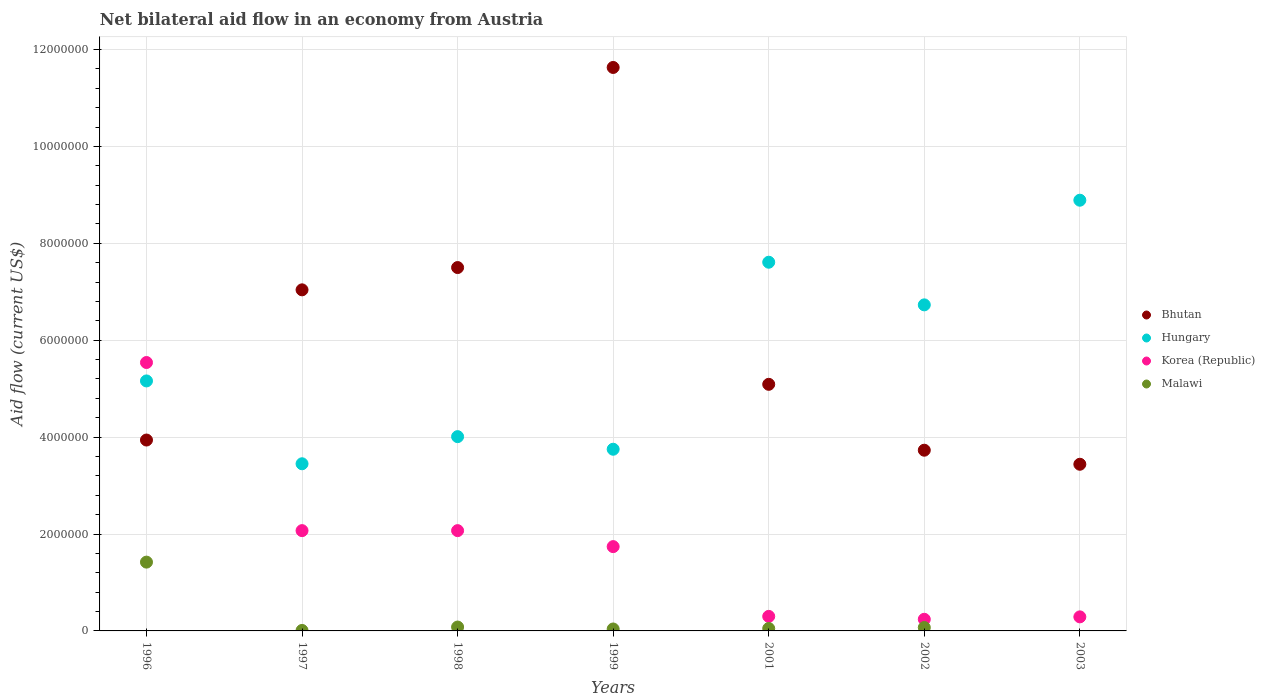How many different coloured dotlines are there?
Your answer should be very brief. 4. What is the net bilateral aid flow in Korea (Republic) in 1997?
Make the answer very short. 2.07e+06. Across all years, what is the maximum net bilateral aid flow in Malawi?
Keep it short and to the point. 1.42e+06. Across all years, what is the minimum net bilateral aid flow in Hungary?
Provide a short and direct response. 3.45e+06. What is the total net bilateral aid flow in Korea (Republic) in the graph?
Offer a terse response. 1.22e+07. What is the difference between the net bilateral aid flow in Hungary in 1998 and the net bilateral aid flow in Malawi in 2003?
Make the answer very short. 4.01e+06. What is the average net bilateral aid flow in Korea (Republic) per year?
Keep it short and to the point. 1.75e+06. In the year 1999, what is the difference between the net bilateral aid flow in Bhutan and net bilateral aid flow in Hungary?
Ensure brevity in your answer.  7.88e+06. What is the ratio of the net bilateral aid flow in Korea (Republic) in 1996 to that in 1999?
Your answer should be very brief. 3.18. Is the net bilateral aid flow in Malawi in 1997 less than that in 1999?
Ensure brevity in your answer.  Yes. Is the difference between the net bilateral aid flow in Bhutan in 1999 and 2003 greater than the difference between the net bilateral aid flow in Hungary in 1999 and 2003?
Provide a succinct answer. Yes. What is the difference between the highest and the second highest net bilateral aid flow in Korea (Republic)?
Your response must be concise. 3.47e+06. What is the difference between the highest and the lowest net bilateral aid flow in Malawi?
Your answer should be compact. 1.42e+06. Is the sum of the net bilateral aid flow in Korea (Republic) in 1999 and 2003 greater than the maximum net bilateral aid flow in Bhutan across all years?
Offer a terse response. No. Is the net bilateral aid flow in Bhutan strictly greater than the net bilateral aid flow in Hungary over the years?
Your answer should be compact. No. Is the net bilateral aid flow in Korea (Republic) strictly less than the net bilateral aid flow in Malawi over the years?
Keep it short and to the point. No. How many dotlines are there?
Your response must be concise. 4. What is the difference between two consecutive major ticks on the Y-axis?
Offer a very short reply. 2.00e+06. Does the graph contain grids?
Make the answer very short. Yes. How many legend labels are there?
Your answer should be compact. 4. What is the title of the graph?
Offer a terse response. Net bilateral aid flow in an economy from Austria. Does "Japan" appear as one of the legend labels in the graph?
Your answer should be very brief. No. What is the label or title of the Y-axis?
Offer a terse response. Aid flow (current US$). What is the Aid flow (current US$) of Bhutan in 1996?
Offer a terse response. 3.94e+06. What is the Aid flow (current US$) of Hungary in 1996?
Give a very brief answer. 5.16e+06. What is the Aid flow (current US$) of Korea (Republic) in 1996?
Your answer should be very brief. 5.54e+06. What is the Aid flow (current US$) in Malawi in 1996?
Make the answer very short. 1.42e+06. What is the Aid flow (current US$) in Bhutan in 1997?
Make the answer very short. 7.04e+06. What is the Aid flow (current US$) in Hungary in 1997?
Offer a terse response. 3.45e+06. What is the Aid flow (current US$) in Korea (Republic) in 1997?
Offer a very short reply. 2.07e+06. What is the Aid flow (current US$) in Bhutan in 1998?
Provide a succinct answer. 7.50e+06. What is the Aid flow (current US$) of Hungary in 1998?
Your answer should be compact. 4.01e+06. What is the Aid flow (current US$) of Korea (Republic) in 1998?
Make the answer very short. 2.07e+06. What is the Aid flow (current US$) of Bhutan in 1999?
Provide a succinct answer. 1.16e+07. What is the Aid flow (current US$) of Hungary in 1999?
Ensure brevity in your answer.  3.75e+06. What is the Aid flow (current US$) in Korea (Republic) in 1999?
Offer a very short reply. 1.74e+06. What is the Aid flow (current US$) in Malawi in 1999?
Make the answer very short. 4.00e+04. What is the Aid flow (current US$) in Bhutan in 2001?
Your response must be concise. 5.09e+06. What is the Aid flow (current US$) in Hungary in 2001?
Your response must be concise. 7.61e+06. What is the Aid flow (current US$) of Bhutan in 2002?
Keep it short and to the point. 3.73e+06. What is the Aid flow (current US$) in Hungary in 2002?
Your answer should be compact. 6.73e+06. What is the Aid flow (current US$) of Korea (Republic) in 2002?
Offer a very short reply. 2.40e+05. What is the Aid flow (current US$) in Malawi in 2002?
Give a very brief answer. 7.00e+04. What is the Aid flow (current US$) in Bhutan in 2003?
Give a very brief answer. 3.44e+06. What is the Aid flow (current US$) of Hungary in 2003?
Keep it short and to the point. 8.89e+06. Across all years, what is the maximum Aid flow (current US$) in Bhutan?
Offer a terse response. 1.16e+07. Across all years, what is the maximum Aid flow (current US$) in Hungary?
Ensure brevity in your answer.  8.89e+06. Across all years, what is the maximum Aid flow (current US$) in Korea (Republic)?
Offer a terse response. 5.54e+06. Across all years, what is the maximum Aid flow (current US$) in Malawi?
Provide a short and direct response. 1.42e+06. Across all years, what is the minimum Aid flow (current US$) of Bhutan?
Give a very brief answer. 3.44e+06. Across all years, what is the minimum Aid flow (current US$) of Hungary?
Provide a short and direct response. 3.45e+06. Across all years, what is the minimum Aid flow (current US$) in Malawi?
Your answer should be compact. 0. What is the total Aid flow (current US$) of Bhutan in the graph?
Your answer should be very brief. 4.24e+07. What is the total Aid flow (current US$) in Hungary in the graph?
Ensure brevity in your answer.  3.96e+07. What is the total Aid flow (current US$) in Korea (Republic) in the graph?
Provide a succinct answer. 1.22e+07. What is the total Aid flow (current US$) in Malawi in the graph?
Offer a very short reply. 1.67e+06. What is the difference between the Aid flow (current US$) of Bhutan in 1996 and that in 1997?
Ensure brevity in your answer.  -3.10e+06. What is the difference between the Aid flow (current US$) in Hungary in 1996 and that in 1997?
Your answer should be compact. 1.71e+06. What is the difference between the Aid flow (current US$) of Korea (Republic) in 1996 and that in 1997?
Provide a succinct answer. 3.47e+06. What is the difference between the Aid flow (current US$) of Malawi in 1996 and that in 1997?
Your answer should be very brief. 1.41e+06. What is the difference between the Aid flow (current US$) in Bhutan in 1996 and that in 1998?
Keep it short and to the point. -3.56e+06. What is the difference between the Aid flow (current US$) of Hungary in 1996 and that in 1998?
Ensure brevity in your answer.  1.15e+06. What is the difference between the Aid flow (current US$) of Korea (Republic) in 1996 and that in 1998?
Provide a short and direct response. 3.47e+06. What is the difference between the Aid flow (current US$) of Malawi in 1996 and that in 1998?
Offer a very short reply. 1.34e+06. What is the difference between the Aid flow (current US$) in Bhutan in 1996 and that in 1999?
Your response must be concise. -7.69e+06. What is the difference between the Aid flow (current US$) in Hungary in 1996 and that in 1999?
Give a very brief answer. 1.41e+06. What is the difference between the Aid flow (current US$) in Korea (Republic) in 1996 and that in 1999?
Provide a short and direct response. 3.80e+06. What is the difference between the Aid flow (current US$) of Malawi in 1996 and that in 1999?
Provide a short and direct response. 1.38e+06. What is the difference between the Aid flow (current US$) in Bhutan in 1996 and that in 2001?
Ensure brevity in your answer.  -1.15e+06. What is the difference between the Aid flow (current US$) of Hungary in 1996 and that in 2001?
Offer a terse response. -2.45e+06. What is the difference between the Aid flow (current US$) in Korea (Republic) in 1996 and that in 2001?
Provide a short and direct response. 5.24e+06. What is the difference between the Aid flow (current US$) of Malawi in 1996 and that in 2001?
Provide a succinct answer. 1.37e+06. What is the difference between the Aid flow (current US$) in Hungary in 1996 and that in 2002?
Offer a very short reply. -1.57e+06. What is the difference between the Aid flow (current US$) of Korea (Republic) in 1996 and that in 2002?
Keep it short and to the point. 5.30e+06. What is the difference between the Aid flow (current US$) in Malawi in 1996 and that in 2002?
Offer a terse response. 1.35e+06. What is the difference between the Aid flow (current US$) in Bhutan in 1996 and that in 2003?
Your answer should be very brief. 5.00e+05. What is the difference between the Aid flow (current US$) in Hungary in 1996 and that in 2003?
Keep it short and to the point. -3.73e+06. What is the difference between the Aid flow (current US$) in Korea (Republic) in 1996 and that in 2003?
Offer a terse response. 5.25e+06. What is the difference between the Aid flow (current US$) in Bhutan in 1997 and that in 1998?
Provide a short and direct response. -4.60e+05. What is the difference between the Aid flow (current US$) of Hungary in 1997 and that in 1998?
Provide a short and direct response. -5.60e+05. What is the difference between the Aid flow (current US$) in Malawi in 1997 and that in 1998?
Your response must be concise. -7.00e+04. What is the difference between the Aid flow (current US$) of Bhutan in 1997 and that in 1999?
Give a very brief answer. -4.59e+06. What is the difference between the Aid flow (current US$) in Hungary in 1997 and that in 1999?
Give a very brief answer. -3.00e+05. What is the difference between the Aid flow (current US$) in Bhutan in 1997 and that in 2001?
Offer a very short reply. 1.95e+06. What is the difference between the Aid flow (current US$) in Hungary in 1997 and that in 2001?
Offer a terse response. -4.16e+06. What is the difference between the Aid flow (current US$) in Korea (Republic) in 1997 and that in 2001?
Make the answer very short. 1.77e+06. What is the difference between the Aid flow (current US$) in Malawi in 1997 and that in 2001?
Provide a short and direct response. -4.00e+04. What is the difference between the Aid flow (current US$) in Bhutan in 1997 and that in 2002?
Your answer should be compact. 3.31e+06. What is the difference between the Aid flow (current US$) of Hungary in 1997 and that in 2002?
Your response must be concise. -3.28e+06. What is the difference between the Aid flow (current US$) of Korea (Republic) in 1997 and that in 2002?
Provide a short and direct response. 1.83e+06. What is the difference between the Aid flow (current US$) in Malawi in 1997 and that in 2002?
Make the answer very short. -6.00e+04. What is the difference between the Aid flow (current US$) in Bhutan in 1997 and that in 2003?
Provide a short and direct response. 3.60e+06. What is the difference between the Aid flow (current US$) of Hungary in 1997 and that in 2003?
Ensure brevity in your answer.  -5.44e+06. What is the difference between the Aid flow (current US$) of Korea (Republic) in 1997 and that in 2003?
Offer a terse response. 1.78e+06. What is the difference between the Aid flow (current US$) in Bhutan in 1998 and that in 1999?
Provide a succinct answer. -4.13e+06. What is the difference between the Aid flow (current US$) of Hungary in 1998 and that in 1999?
Your answer should be compact. 2.60e+05. What is the difference between the Aid flow (current US$) in Bhutan in 1998 and that in 2001?
Provide a succinct answer. 2.41e+06. What is the difference between the Aid flow (current US$) of Hungary in 1998 and that in 2001?
Give a very brief answer. -3.60e+06. What is the difference between the Aid flow (current US$) in Korea (Republic) in 1998 and that in 2001?
Offer a terse response. 1.77e+06. What is the difference between the Aid flow (current US$) in Malawi in 1998 and that in 2001?
Ensure brevity in your answer.  3.00e+04. What is the difference between the Aid flow (current US$) of Bhutan in 1998 and that in 2002?
Keep it short and to the point. 3.77e+06. What is the difference between the Aid flow (current US$) of Hungary in 1998 and that in 2002?
Give a very brief answer. -2.72e+06. What is the difference between the Aid flow (current US$) of Korea (Republic) in 1998 and that in 2002?
Provide a succinct answer. 1.83e+06. What is the difference between the Aid flow (current US$) in Malawi in 1998 and that in 2002?
Make the answer very short. 10000. What is the difference between the Aid flow (current US$) of Bhutan in 1998 and that in 2003?
Keep it short and to the point. 4.06e+06. What is the difference between the Aid flow (current US$) in Hungary in 1998 and that in 2003?
Keep it short and to the point. -4.88e+06. What is the difference between the Aid flow (current US$) of Korea (Republic) in 1998 and that in 2003?
Give a very brief answer. 1.78e+06. What is the difference between the Aid flow (current US$) of Bhutan in 1999 and that in 2001?
Your answer should be compact. 6.54e+06. What is the difference between the Aid flow (current US$) of Hungary in 1999 and that in 2001?
Make the answer very short. -3.86e+06. What is the difference between the Aid flow (current US$) of Korea (Republic) in 1999 and that in 2001?
Your answer should be compact. 1.44e+06. What is the difference between the Aid flow (current US$) in Bhutan in 1999 and that in 2002?
Give a very brief answer. 7.90e+06. What is the difference between the Aid flow (current US$) in Hungary in 1999 and that in 2002?
Provide a succinct answer. -2.98e+06. What is the difference between the Aid flow (current US$) in Korea (Republic) in 1999 and that in 2002?
Provide a succinct answer. 1.50e+06. What is the difference between the Aid flow (current US$) in Bhutan in 1999 and that in 2003?
Provide a short and direct response. 8.19e+06. What is the difference between the Aid flow (current US$) in Hungary in 1999 and that in 2003?
Your answer should be very brief. -5.14e+06. What is the difference between the Aid flow (current US$) in Korea (Republic) in 1999 and that in 2003?
Provide a succinct answer. 1.45e+06. What is the difference between the Aid flow (current US$) in Bhutan in 2001 and that in 2002?
Your answer should be compact. 1.36e+06. What is the difference between the Aid flow (current US$) of Hungary in 2001 and that in 2002?
Give a very brief answer. 8.80e+05. What is the difference between the Aid flow (current US$) in Korea (Republic) in 2001 and that in 2002?
Provide a short and direct response. 6.00e+04. What is the difference between the Aid flow (current US$) in Bhutan in 2001 and that in 2003?
Keep it short and to the point. 1.65e+06. What is the difference between the Aid flow (current US$) of Hungary in 2001 and that in 2003?
Provide a short and direct response. -1.28e+06. What is the difference between the Aid flow (current US$) of Korea (Republic) in 2001 and that in 2003?
Your response must be concise. 10000. What is the difference between the Aid flow (current US$) in Hungary in 2002 and that in 2003?
Keep it short and to the point. -2.16e+06. What is the difference between the Aid flow (current US$) in Bhutan in 1996 and the Aid flow (current US$) in Hungary in 1997?
Offer a very short reply. 4.90e+05. What is the difference between the Aid flow (current US$) of Bhutan in 1996 and the Aid flow (current US$) of Korea (Republic) in 1997?
Your answer should be very brief. 1.87e+06. What is the difference between the Aid flow (current US$) of Bhutan in 1996 and the Aid flow (current US$) of Malawi in 1997?
Offer a terse response. 3.93e+06. What is the difference between the Aid flow (current US$) in Hungary in 1996 and the Aid flow (current US$) in Korea (Republic) in 1997?
Provide a succinct answer. 3.09e+06. What is the difference between the Aid flow (current US$) of Hungary in 1996 and the Aid flow (current US$) of Malawi in 1997?
Provide a short and direct response. 5.15e+06. What is the difference between the Aid flow (current US$) of Korea (Republic) in 1996 and the Aid flow (current US$) of Malawi in 1997?
Your answer should be compact. 5.53e+06. What is the difference between the Aid flow (current US$) in Bhutan in 1996 and the Aid flow (current US$) in Hungary in 1998?
Your answer should be very brief. -7.00e+04. What is the difference between the Aid flow (current US$) in Bhutan in 1996 and the Aid flow (current US$) in Korea (Republic) in 1998?
Provide a succinct answer. 1.87e+06. What is the difference between the Aid flow (current US$) of Bhutan in 1996 and the Aid flow (current US$) of Malawi in 1998?
Your response must be concise. 3.86e+06. What is the difference between the Aid flow (current US$) of Hungary in 1996 and the Aid flow (current US$) of Korea (Republic) in 1998?
Make the answer very short. 3.09e+06. What is the difference between the Aid flow (current US$) in Hungary in 1996 and the Aid flow (current US$) in Malawi in 1998?
Make the answer very short. 5.08e+06. What is the difference between the Aid flow (current US$) of Korea (Republic) in 1996 and the Aid flow (current US$) of Malawi in 1998?
Offer a very short reply. 5.46e+06. What is the difference between the Aid flow (current US$) in Bhutan in 1996 and the Aid flow (current US$) in Korea (Republic) in 1999?
Offer a very short reply. 2.20e+06. What is the difference between the Aid flow (current US$) of Bhutan in 1996 and the Aid flow (current US$) of Malawi in 1999?
Provide a short and direct response. 3.90e+06. What is the difference between the Aid flow (current US$) of Hungary in 1996 and the Aid flow (current US$) of Korea (Republic) in 1999?
Make the answer very short. 3.42e+06. What is the difference between the Aid flow (current US$) of Hungary in 1996 and the Aid flow (current US$) of Malawi in 1999?
Make the answer very short. 5.12e+06. What is the difference between the Aid flow (current US$) of Korea (Republic) in 1996 and the Aid flow (current US$) of Malawi in 1999?
Ensure brevity in your answer.  5.50e+06. What is the difference between the Aid flow (current US$) in Bhutan in 1996 and the Aid flow (current US$) in Hungary in 2001?
Make the answer very short. -3.67e+06. What is the difference between the Aid flow (current US$) of Bhutan in 1996 and the Aid flow (current US$) of Korea (Republic) in 2001?
Your response must be concise. 3.64e+06. What is the difference between the Aid flow (current US$) of Bhutan in 1996 and the Aid flow (current US$) of Malawi in 2001?
Offer a very short reply. 3.89e+06. What is the difference between the Aid flow (current US$) of Hungary in 1996 and the Aid flow (current US$) of Korea (Republic) in 2001?
Your answer should be very brief. 4.86e+06. What is the difference between the Aid flow (current US$) of Hungary in 1996 and the Aid flow (current US$) of Malawi in 2001?
Make the answer very short. 5.11e+06. What is the difference between the Aid flow (current US$) in Korea (Republic) in 1996 and the Aid flow (current US$) in Malawi in 2001?
Provide a succinct answer. 5.49e+06. What is the difference between the Aid flow (current US$) of Bhutan in 1996 and the Aid flow (current US$) of Hungary in 2002?
Give a very brief answer. -2.79e+06. What is the difference between the Aid flow (current US$) of Bhutan in 1996 and the Aid flow (current US$) of Korea (Republic) in 2002?
Make the answer very short. 3.70e+06. What is the difference between the Aid flow (current US$) of Bhutan in 1996 and the Aid flow (current US$) of Malawi in 2002?
Ensure brevity in your answer.  3.87e+06. What is the difference between the Aid flow (current US$) in Hungary in 1996 and the Aid flow (current US$) in Korea (Republic) in 2002?
Your answer should be compact. 4.92e+06. What is the difference between the Aid flow (current US$) of Hungary in 1996 and the Aid flow (current US$) of Malawi in 2002?
Make the answer very short. 5.09e+06. What is the difference between the Aid flow (current US$) of Korea (Republic) in 1996 and the Aid flow (current US$) of Malawi in 2002?
Provide a short and direct response. 5.47e+06. What is the difference between the Aid flow (current US$) of Bhutan in 1996 and the Aid flow (current US$) of Hungary in 2003?
Offer a terse response. -4.95e+06. What is the difference between the Aid flow (current US$) of Bhutan in 1996 and the Aid flow (current US$) of Korea (Republic) in 2003?
Offer a terse response. 3.65e+06. What is the difference between the Aid flow (current US$) in Hungary in 1996 and the Aid flow (current US$) in Korea (Republic) in 2003?
Provide a short and direct response. 4.87e+06. What is the difference between the Aid flow (current US$) of Bhutan in 1997 and the Aid flow (current US$) of Hungary in 1998?
Give a very brief answer. 3.03e+06. What is the difference between the Aid flow (current US$) of Bhutan in 1997 and the Aid flow (current US$) of Korea (Republic) in 1998?
Keep it short and to the point. 4.97e+06. What is the difference between the Aid flow (current US$) in Bhutan in 1997 and the Aid flow (current US$) in Malawi in 1998?
Provide a short and direct response. 6.96e+06. What is the difference between the Aid flow (current US$) of Hungary in 1997 and the Aid flow (current US$) of Korea (Republic) in 1998?
Your answer should be compact. 1.38e+06. What is the difference between the Aid flow (current US$) of Hungary in 1997 and the Aid flow (current US$) of Malawi in 1998?
Provide a succinct answer. 3.37e+06. What is the difference between the Aid flow (current US$) in Korea (Republic) in 1997 and the Aid flow (current US$) in Malawi in 1998?
Offer a very short reply. 1.99e+06. What is the difference between the Aid flow (current US$) of Bhutan in 1997 and the Aid flow (current US$) of Hungary in 1999?
Keep it short and to the point. 3.29e+06. What is the difference between the Aid flow (current US$) of Bhutan in 1997 and the Aid flow (current US$) of Korea (Republic) in 1999?
Ensure brevity in your answer.  5.30e+06. What is the difference between the Aid flow (current US$) in Hungary in 1997 and the Aid flow (current US$) in Korea (Republic) in 1999?
Provide a short and direct response. 1.71e+06. What is the difference between the Aid flow (current US$) in Hungary in 1997 and the Aid flow (current US$) in Malawi in 1999?
Provide a short and direct response. 3.41e+06. What is the difference between the Aid flow (current US$) in Korea (Republic) in 1997 and the Aid flow (current US$) in Malawi in 1999?
Make the answer very short. 2.03e+06. What is the difference between the Aid flow (current US$) of Bhutan in 1997 and the Aid flow (current US$) of Hungary in 2001?
Ensure brevity in your answer.  -5.70e+05. What is the difference between the Aid flow (current US$) in Bhutan in 1997 and the Aid flow (current US$) in Korea (Republic) in 2001?
Provide a short and direct response. 6.74e+06. What is the difference between the Aid flow (current US$) of Bhutan in 1997 and the Aid flow (current US$) of Malawi in 2001?
Your response must be concise. 6.99e+06. What is the difference between the Aid flow (current US$) in Hungary in 1997 and the Aid flow (current US$) in Korea (Republic) in 2001?
Your response must be concise. 3.15e+06. What is the difference between the Aid flow (current US$) of Hungary in 1997 and the Aid flow (current US$) of Malawi in 2001?
Your response must be concise. 3.40e+06. What is the difference between the Aid flow (current US$) in Korea (Republic) in 1997 and the Aid flow (current US$) in Malawi in 2001?
Offer a very short reply. 2.02e+06. What is the difference between the Aid flow (current US$) of Bhutan in 1997 and the Aid flow (current US$) of Hungary in 2002?
Give a very brief answer. 3.10e+05. What is the difference between the Aid flow (current US$) in Bhutan in 1997 and the Aid flow (current US$) in Korea (Republic) in 2002?
Offer a very short reply. 6.80e+06. What is the difference between the Aid flow (current US$) of Bhutan in 1997 and the Aid flow (current US$) of Malawi in 2002?
Your answer should be very brief. 6.97e+06. What is the difference between the Aid flow (current US$) of Hungary in 1997 and the Aid flow (current US$) of Korea (Republic) in 2002?
Your answer should be very brief. 3.21e+06. What is the difference between the Aid flow (current US$) in Hungary in 1997 and the Aid flow (current US$) in Malawi in 2002?
Keep it short and to the point. 3.38e+06. What is the difference between the Aid flow (current US$) in Korea (Republic) in 1997 and the Aid flow (current US$) in Malawi in 2002?
Offer a very short reply. 2.00e+06. What is the difference between the Aid flow (current US$) of Bhutan in 1997 and the Aid flow (current US$) of Hungary in 2003?
Offer a very short reply. -1.85e+06. What is the difference between the Aid flow (current US$) of Bhutan in 1997 and the Aid flow (current US$) of Korea (Republic) in 2003?
Your answer should be compact. 6.75e+06. What is the difference between the Aid flow (current US$) of Hungary in 1997 and the Aid flow (current US$) of Korea (Republic) in 2003?
Make the answer very short. 3.16e+06. What is the difference between the Aid flow (current US$) in Bhutan in 1998 and the Aid flow (current US$) in Hungary in 1999?
Your answer should be compact. 3.75e+06. What is the difference between the Aid flow (current US$) in Bhutan in 1998 and the Aid flow (current US$) in Korea (Republic) in 1999?
Your answer should be very brief. 5.76e+06. What is the difference between the Aid flow (current US$) in Bhutan in 1998 and the Aid flow (current US$) in Malawi in 1999?
Make the answer very short. 7.46e+06. What is the difference between the Aid flow (current US$) in Hungary in 1998 and the Aid flow (current US$) in Korea (Republic) in 1999?
Make the answer very short. 2.27e+06. What is the difference between the Aid flow (current US$) in Hungary in 1998 and the Aid flow (current US$) in Malawi in 1999?
Ensure brevity in your answer.  3.97e+06. What is the difference between the Aid flow (current US$) of Korea (Republic) in 1998 and the Aid flow (current US$) of Malawi in 1999?
Offer a terse response. 2.03e+06. What is the difference between the Aid flow (current US$) of Bhutan in 1998 and the Aid flow (current US$) of Hungary in 2001?
Provide a succinct answer. -1.10e+05. What is the difference between the Aid flow (current US$) of Bhutan in 1998 and the Aid flow (current US$) of Korea (Republic) in 2001?
Your answer should be very brief. 7.20e+06. What is the difference between the Aid flow (current US$) of Bhutan in 1998 and the Aid flow (current US$) of Malawi in 2001?
Give a very brief answer. 7.45e+06. What is the difference between the Aid flow (current US$) in Hungary in 1998 and the Aid flow (current US$) in Korea (Republic) in 2001?
Your answer should be very brief. 3.71e+06. What is the difference between the Aid flow (current US$) in Hungary in 1998 and the Aid flow (current US$) in Malawi in 2001?
Make the answer very short. 3.96e+06. What is the difference between the Aid flow (current US$) of Korea (Republic) in 1998 and the Aid flow (current US$) of Malawi in 2001?
Offer a terse response. 2.02e+06. What is the difference between the Aid flow (current US$) of Bhutan in 1998 and the Aid flow (current US$) of Hungary in 2002?
Keep it short and to the point. 7.70e+05. What is the difference between the Aid flow (current US$) in Bhutan in 1998 and the Aid flow (current US$) in Korea (Republic) in 2002?
Offer a terse response. 7.26e+06. What is the difference between the Aid flow (current US$) of Bhutan in 1998 and the Aid flow (current US$) of Malawi in 2002?
Your response must be concise. 7.43e+06. What is the difference between the Aid flow (current US$) in Hungary in 1998 and the Aid flow (current US$) in Korea (Republic) in 2002?
Offer a very short reply. 3.77e+06. What is the difference between the Aid flow (current US$) in Hungary in 1998 and the Aid flow (current US$) in Malawi in 2002?
Give a very brief answer. 3.94e+06. What is the difference between the Aid flow (current US$) of Korea (Republic) in 1998 and the Aid flow (current US$) of Malawi in 2002?
Offer a terse response. 2.00e+06. What is the difference between the Aid flow (current US$) in Bhutan in 1998 and the Aid flow (current US$) in Hungary in 2003?
Offer a terse response. -1.39e+06. What is the difference between the Aid flow (current US$) in Bhutan in 1998 and the Aid flow (current US$) in Korea (Republic) in 2003?
Make the answer very short. 7.21e+06. What is the difference between the Aid flow (current US$) in Hungary in 1998 and the Aid flow (current US$) in Korea (Republic) in 2003?
Offer a terse response. 3.72e+06. What is the difference between the Aid flow (current US$) in Bhutan in 1999 and the Aid flow (current US$) in Hungary in 2001?
Provide a succinct answer. 4.02e+06. What is the difference between the Aid flow (current US$) of Bhutan in 1999 and the Aid flow (current US$) of Korea (Republic) in 2001?
Give a very brief answer. 1.13e+07. What is the difference between the Aid flow (current US$) in Bhutan in 1999 and the Aid flow (current US$) in Malawi in 2001?
Your answer should be compact. 1.16e+07. What is the difference between the Aid flow (current US$) in Hungary in 1999 and the Aid flow (current US$) in Korea (Republic) in 2001?
Give a very brief answer. 3.45e+06. What is the difference between the Aid flow (current US$) of Hungary in 1999 and the Aid flow (current US$) of Malawi in 2001?
Your answer should be compact. 3.70e+06. What is the difference between the Aid flow (current US$) of Korea (Republic) in 1999 and the Aid flow (current US$) of Malawi in 2001?
Offer a very short reply. 1.69e+06. What is the difference between the Aid flow (current US$) of Bhutan in 1999 and the Aid flow (current US$) of Hungary in 2002?
Offer a terse response. 4.90e+06. What is the difference between the Aid flow (current US$) of Bhutan in 1999 and the Aid flow (current US$) of Korea (Republic) in 2002?
Your answer should be very brief. 1.14e+07. What is the difference between the Aid flow (current US$) of Bhutan in 1999 and the Aid flow (current US$) of Malawi in 2002?
Your response must be concise. 1.16e+07. What is the difference between the Aid flow (current US$) in Hungary in 1999 and the Aid flow (current US$) in Korea (Republic) in 2002?
Provide a succinct answer. 3.51e+06. What is the difference between the Aid flow (current US$) in Hungary in 1999 and the Aid flow (current US$) in Malawi in 2002?
Give a very brief answer. 3.68e+06. What is the difference between the Aid flow (current US$) in Korea (Republic) in 1999 and the Aid flow (current US$) in Malawi in 2002?
Give a very brief answer. 1.67e+06. What is the difference between the Aid flow (current US$) in Bhutan in 1999 and the Aid flow (current US$) in Hungary in 2003?
Provide a succinct answer. 2.74e+06. What is the difference between the Aid flow (current US$) of Bhutan in 1999 and the Aid flow (current US$) of Korea (Republic) in 2003?
Your answer should be compact. 1.13e+07. What is the difference between the Aid flow (current US$) in Hungary in 1999 and the Aid flow (current US$) in Korea (Republic) in 2003?
Your answer should be very brief. 3.46e+06. What is the difference between the Aid flow (current US$) in Bhutan in 2001 and the Aid flow (current US$) in Hungary in 2002?
Your answer should be compact. -1.64e+06. What is the difference between the Aid flow (current US$) of Bhutan in 2001 and the Aid flow (current US$) of Korea (Republic) in 2002?
Your response must be concise. 4.85e+06. What is the difference between the Aid flow (current US$) in Bhutan in 2001 and the Aid flow (current US$) in Malawi in 2002?
Make the answer very short. 5.02e+06. What is the difference between the Aid flow (current US$) in Hungary in 2001 and the Aid flow (current US$) in Korea (Republic) in 2002?
Your answer should be very brief. 7.37e+06. What is the difference between the Aid flow (current US$) of Hungary in 2001 and the Aid flow (current US$) of Malawi in 2002?
Make the answer very short. 7.54e+06. What is the difference between the Aid flow (current US$) of Bhutan in 2001 and the Aid flow (current US$) of Hungary in 2003?
Keep it short and to the point. -3.80e+06. What is the difference between the Aid flow (current US$) in Bhutan in 2001 and the Aid flow (current US$) in Korea (Republic) in 2003?
Keep it short and to the point. 4.80e+06. What is the difference between the Aid flow (current US$) in Hungary in 2001 and the Aid flow (current US$) in Korea (Republic) in 2003?
Give a very brief answer. 7.32e+06. What is the difference between the Aid flow (current US$) in Bhutan in 2002 and the Aid flow (current US$) in Hungary in 2003?
Your answer should be compact. -5.16e+06. What is the difference between the Aid flow (current US$) of Bhutan in 2002 and the Aid flow (current US$) of Korea (Republic) in 2003?
Your answer should be compact. 3.44e+06. What is the difference between the Aid flow (current US$) of Hungary in 2002 and the Aid flow (current US$) of Korea (Republic) in 2003?
Your answer should be very brief. 6.44e+06. What is the average Aid flow (current US$) of Bhutan per year?
Keep it short and to the point. 6.05e+06. What is the average Aid flow (current US$) in Hungary per year?
Your response must be concise. 5.66e+06. What is the average Aid flow (current US$) in Korea (Republic) per year?
Provide a short and direct response. 1.75e+06. What is the average Aid flow (current US$) in Malawi per year?
Provide a succinct answer. 2.39e+05. In the year 1996, what is the difference between the Aid flow (current US$) of Bhutan and Aid flow (current US$) of Hungary?
Offer a terse response. -1.22e+06. In the year 1996, what is the difference between the Aid flow (current US$) in Bhutan and Aid flow (current US$) in Korea (Republic)?
Ensure brevity in your answer.  -1.60e+06. In the year 1996, what is the difference between the Aid flow (current US$) in Bhutan and Aid flow (current US$) in Malawi?
Provide a succinct answer. 2.52e+06. In the year 1996, what is the difference between the Aid flow (current US$) in Hungary and Aid flow (current US$) in Korea (Republic)?
Ensure brevity in your answer.  -3.80e+05. In the year 1996, what is the difference between the Aid flow (current US$) in Hungary and Aid flow (current US$) in Malawi?
Your response must be concise. 3.74e+06. In the year 1996, what is the difference between the Aid flow (current US$) in Korea (Republic) and Aid flow (current US$) in Malawi?
Offer a terse response. 4.12e+06. In the year 1997, what is the difference between the Aid flow (current US$) in Bhutan and Aid flow (current US$) in Hungary?
Provide a short and direct response. 3.59e+06. In the year 1997, what is the difference between the Aid flow (current US$) of Bhutan and Aid flow (current US$) of Korea (Republic)?
Ensure brevity in your answer.  4.97e+06. In the year 1997, what is the difference between the Aid flow (current US$) of Bhutan and Aid flow (current US$) of Malawi?
Offer a terse response. 7.03e+06. In the year 1997, what is the difference between the Aid flow (current US$) of Hungary and Aid flow (current US$) of Korea (Republic)?
Ensure brevity in your answer.  1.38e+06. In the year 1997, what is the difference between the Aid flow (current US$) in Hungary and Aid flow (current US$) in Malawi?
Provide a short and direct response. 3.44e+06. In the year 1997, what is the difference between the Aid flow (current US$) of Korea (Republic) and Aid flow (current US$) of Malawi?
Provide a short and direct response. 2.06e+06. In the year 1998, what is the difference between the Aid flow (current US$) in Bhutan and Aid flow (current US$) in Hungary?
Your answer should be compact. 3.49e+06. In the year 1998, what is the difference between the Aid flow (current US$) in Bhutan and Aid flow (current US$) in Korea (Republic)?
Your response must be concise. 5.43e+06. In the year 1998, what is the difference between the Aid flow (current US$) in Bhutan and Aid flow (current US$) in Malawi?
Provide a succinct answer. 7.42e+06. In the year 1998, what is the difference between the Aid flow (current US$) of Hungary and Aid flow (current US$) of Korea (Republic)?
Give a very brief answer. 1.94e+06. In the year 1998, what is the difference between the Aid flow (current US$) of Hungary and Aid flow (current US$) of Malawi?
Your answer should be compact. 3.93e+06. In the year 1998, what is the difference between the Aid flow (current US$) of Korea (Republic) and Aid flow (current US$) of Malawi?
Your answer should be very brief. 1.99e+06. In the year 1999, what is the difference between the Aid flow (current US$) in Bhutan and Aid flow (current US$) in Hungary?
Give a very brief answer. 7.88e+06. In the year 1999, what is the difference between the Aid flow (current US$) of Bhutan and Aid flow (current US$) of Korea (Republic)?
Offer a terse response. 9.89e+06. In the year 1999, what is the difference between the Aid flow (current US$) of Bhutan and Aid flow (current US$) of Malawi?
Offer a very short reply. 1.16e+07. In the year 1999, what is the difference between the Aid flow (current US$) of Hungary and Aid flow (current US$) of Korea (Republic)?
Your response must be concise. 2.01e+06. In the year 1999, what is the difference between the Aid flow (current US$) in Hungary and Aid flow (current US$) in Malawi?
Your response must be concise. 3.71e+06. In the year 1999, what is the difference between the Aid flow (current US$) in Korea (Republic) and Aid flow (current US$) in Malawi?
Keep it short and to the point. 1.70e+06. In the year 2001, what is the difference between the Aid flow (current US$) of Bhutan and Aid flow (current US$) of Hungary?
Offer a very short reply. -2.52e+06. In the year 2001, what is the difference between the Aid flow (current US$) of Bhutan and Aid flow (current US$) of Korea (Republic)?
Provide a succinct answer. 4.79e+06. In the year 2001, what is the difference between the Aid flow (current US$) in Bhutan and Aid flow (current US$) in Malawi?
Your answer should be compact. 5.04e+06. In the year 2001, what is the difference between the Aid flow (current US$) in Hungary and Aid flow (current US$) in Korea (Republic)?
Offer a terse response. 7.31e+06. In the year 2001, what is the difference between the Aid flow (current US$) of Hungary and Aid flow (current US$) of Malawi?
Provide a succinct answer. 7.56e+06. In the year 2002, what is the difference between the Aid flow (current US$) of Bhutan and Aid flow (current US$) of Hungary?
Ensure brevity in your answer.  -3.00e+06. In the year 2002, what is the difference between the Aid flow (current US$) in Bhutan and Aid flow (current US$) in Korea (Republic)?
Ensure brevity in your answer.  3.49e+06. In the year 2002, what is the difference between the Aid flow (current US$) in Bhutan and Aid flow (current US$) in Malawi?
Make the answer very short. 3.66e+06. In the year 2002, what is the difference between the Aid flow (current US$) of Hungary and Aid flow (current US$) of Korea (Republic)?
Your response must be concise. 6.49e+06. In the year 2002, what is the difference between the Aid flow (current US$) of Hungary and Aid flow (current US$) of Malawi?
Offer a terse response. 6.66e+06. In the year 2003, what is the difference between the Aid flow (current US$) of Bhutan and Aid flow (current US$) of Hungary?
Your answer should be very brief. -5.45e+06. In the year 2003, what is the difference between the Aid flow (current US$) in Bhutan and Aid flow (current US$) in Korea (Republic)?
Ensure brevity in your answer.  3.15e+06. In the year 2003, what is the difference between the Aid flow (current US$) in Hungary and Aid flow (current US$) in Korea (Republic)?
Keep it short and to the point. 8.60e+06. What is the ratio of the Aid flow (current US$) in Bhutan in 1996 to that in 1997?
Make the answer very short. 0.56. What is the ratio of the Aid flow (current US$) of Hungary in 1996 to that in 1997?
Make the answer very short. 1.5. What is the ratio of the Aid flow (current US$) in Korea (Republic) in 1996 to that in 1997?
Give a very brief answer. 2.68. What is the ratio of the Aid flow (current US$) in Malawi in 1996 to that in 1997?
Give a very brief answer. 142. What is the ratio of the Aid flow (current US$) of Bhutan in 1996 to that in 1998?
Provide a succinct answer. 0.53. What is the ratio of the Aid flow (current US$) in Hungary in 1996 to that in 1998?
Your response must be concise. 1.29. What is the ratio of the Aid flow (current US$) of Korea (Republic) in 1996 to that in 1998?
Provide a short and direct response. 2.68. What is the ratio of the Aid flow (current US$) of Malawi in 1996 to that in 1998?
Make the answer very short. 17.75. What is the ratio of the Aid flow (current US$) of Bhutan in 1996 to that in 1999?
Offer a terse response. 0.34. What is the ratio of the Aid flow (current US$) of Hungary in 1996 to that in 1999?
Ensure brevity in your answer.  1.38. What is the ratio of the Aid flow (current US$) in Korea (Republic) in 1996 to that in 1999?
Provide a short and direct response. 3.18. What is the ratio of the Aid flow (current US$) of Malawi in 1996 to that in 1999?
Your answer should be compact. 35.5. What is the ratio of the Aid flow (current US$) in Bhutan in 1996 to that in 2001?
Ensure brevity in your answer.  0.77. What is the ratio of the Aid flow (current US$) in Hungary in 1996 to that in 2001?
Your answer should be compact. 0.68. What is the ratio of the Aid flow (current US$) of Korea (Republic) in 1996 to that in 2001?
Give a very brief answer. 18.47. What is the ratio of the Aid flow (current US$) of Malawi in 1996 to that in 2001?
Keep it short and to the point. 28.4. What is the ratio of the Aid flow (current US$) of Bhutan in 1996 to that in 2002?
Offer a very short reply. 1.06. What is the ratio of the Aid flow (current US$) in Hungary in 1996 to that in 2002?
Provide a short and direct response. 0.77. What is the ratio of the Aid flow (current US$) of Korea (Republic) in 1996 to that in 2002?
Your response must be concise. 23.08. What is the ratio of the Aid flow (current US$) of Malawi in 1996 to that in 2002?
Provide a short and direct response. 20.29. What is the ratio of the Aid flow (current US$) of Bhutan in 1996 to that in 2003?
Give a very brief answer. 1.15. What is the ratio of the Aid flow (current US$) in Hungary in 1996 to that in 2003?
Offer a very short reply. 0.58. What is the ratio of the Aid flow (current US$) of Korea (Republic) in 1996 to that in 2003?
Your answer should be very brief. 19.1. What is the ratio of the Aid flow (current US$) of Bhutan in 1997 to that in 1998?
Your answer should be compact. 0.94. What is the ratio of the Aid flow (current US$) in Hungary in 1997 to that in 1998?
Offer a terse response. 0.86. What is the ratio of the Aid flow (current US$) of Malawi in 1997 to that in 1998?
Give a very brief answer. 0.12. What is the ratio of the Aid flow (current US$) of Bhutan in 1997 to that in 1999?
Your response must be concise. 0.61. What is the ratio of the Aid flow (current US$) in Hungary in 1997 to that in 1999?
Give a very brief answer. 0.92. What is the ratio of the Aid flow (current US$) in Korea (Republic) in 1997 to that in 1999?
Ensure brevity in your answer.  1.19. What is the ratio of the Aid flow (current US$) of Malawi in 1997 to that in 1999?
Keep it short and to the point. 0.25. What is the ratio of the Aid flow (current US$) in Bhutan in 1997 to that in 2001?
Offer a very short reply. 1.38. What is the ratio of the Aid flow (current US$) in Hungary in 1997 to that in 2001?
Your answer should be very brief. 0.45. What is the ratio of the Aid flow (current US$) in Korea (Republic) in 1997 to that in 2001?
Ensure brevity in your answer.  6.9. What is the ratio of the Aid flow (current US$) of Bhutan in 1997 to that in 2002?
Provide a short and direct response. 1.89. What is the ratio of the Aid flow (current US$) of Hungary in 1997 to that in 2002?
Your answer should be very brief. 0.51. What is the ratio of the Aid flow (current US$) in Korea (Republic) in 1997 to that in 2002?
Ensure brevity in your answer.  8.62. What is the ratio of the Aid flow (current US$) in Malawi in 1997 to that in 2002?
Ensure brevity in your answer.  0.14. What is the ratio of the Aid flow (current US$) in Bhutan in 1997 to that in 2003?
Provide a succinct answer. 2.05. What is the ratio of the Aid flow (current US$) in Hungary in 1997 to that in 2003?
Provide a succinct answer. 0.39. What is the ratio of the Aid flow (current US$) of Korea (Republic) in 1997 to that in 2003?
Your response must be concise. 7.14. What is the ratio of the Aid flow (current US$) of Bhutan in 1998 to that in 1999?
Offer a terse response. 0.64. What is the ratio of the Aid flow (current US$) of Hungary in 1998 to that in 1999?
Provide a succinct answer. 1.07. What is the ratio of the Aid flow (current US$) in Korea (Republic) in 1998 to that in 1999?
Offer a very short reply. 1.19. What is the ratio of the Aid flow (current US$) of Bhutan in 1998 to that in 2001?
Keep it short and to the point. 1.47. What is the ratio of the Aid flow (current US$) of Hungary in 1998 to that in 2001?
Ensure brevity in your answer.  0.53. What is the ratio of the Aid flow (current US$) of Malawi in 1998 to that in 2001?
Give a very brief answer. 1.6. What is the ratio of the Aid flow (current US$) in Bhutan in 1998 to that in 2002?
Make the answer very short. 2.01. What is the ratio of the Aid flow (current US$) in Hungary in 1998 to that in 2002?
Provide a succinct answer. 0.6. What is the ratio of the Aid flow (current US$) of Korea (Republic) in 1998 to that in 2002?
Give a very brief answer. 8.62. What is the ratio of the Aid flow (current US$) of Bhutan in 1998 to that in 2003?
Provide a succinct answer. 2.18. What is the ratio of the Aid flow (current US$) in Hungary in 1998 to that in 2003?
Your answer should be compact. 0.45. What is the ratio of the Aid flow (current US$) in Korea (Republic) in 1998 to that in 2003?
Your response must be concise. 7.14. What is the ratio of the Aid flow (current US$) in Bhutan in 1999 to that in 2001?
Your answer should be compact. 2.28. What is the ratio of the Aid flow (current US$) of Hungary in 1999 to that in 2001?
Offer a terse response. 0.49. What is the ratio of the Aid flow (current US$) in Malawi in 1999 to that in 2001?
Your response must be concise. 0.8. What is the ratio of the Aid flow (current US$) of Bhutan in 1999 to that in 2002?
Your answer should be compact. 3.12. What is the ratio of the Aid flow (current US$) in Hungary in 1999 to that in 2002?
Your answer should be very brief. 0.56. What is the ratio of the Aid flow (current US$) of Korea (Republic) in 1999 to that in 2002?
Provide a succinct answer. 7.25. What is the ratio of the Aid flow (current US$) in Malawi in 1999 to that in 2002?
Your response must be concise. 0.57. What is the ratio of the Aid flow (current US$) in Bhutan in 1999 to that in 2003?
Provide a succinct answer. 3.38. What is the ratio of the Aid flow (current US$) in Hungary in 1999 to that in 2003?
Give a very brief answer. 0.42. What is the ratio of the Aid flow (current US$) of Korea (Republic) in 1999 to that in 2003?
Provide a short and direct response. 6. What is the ratio of the Aid flow (current US$) in Bhutan in 2001 to that in 2002?
Ensure brevity in your answer.  1.36. What is the ratio of the Aid flow (current US$) in Hungary in 2001 to that in 2002?
Ensure brevity in your answer.  1.13. What is the ratio of the Aid flow (current US$) of Korea (Republic) in 2001 to that in 2002?
Offer a terse response. 1.25. What is the ratio of the Aid flow (current US$) of Malawi in 2001 to that in 2002?
Your response must be concise. 0.71. What is the ratio of the Aid flow (current US$) in Bhutan in 2001 to that in 2003?
Offer a terse response. 1.48. What is the ratio of the Aid flow (current US$) of Hungary in 2001 to that in 2003?
Make the answer very short. 0.86. What is the ratio of the Aid flow (current US$) in Korea (Republic) in 2001 to that in 2003?
Keep it short and to the point. 1.03. What is the ratio of the Aid flow (current US$) in Bhutan in 2002 to that in 2003?
Ensure brevity in your answer.  1.08. What is the ratio of the Aid flow (current US$) in Hungary in 2002 to that in 2003?
Offer a very short reply. 0.76. What is the ratio of the Aid flow (current US$) in Korea (Republic) in 2002 to that in 2003?
Your answer should be compact. 0.83. What is the difference between the highest and the second highest Aid flow (current US$) of Bhutan?
Your response must be concise. 4.13e+06. What is the difference between the highest and the second highest Aid flow (current US$) in Hungary?
Provide a succinct answer. 1.28e+06. What is the difference between the highest and the second highest Aid flow (current US$) in Korea (Republic)?
Your answer should be compact. 3.47e+06. What is the difference between the highest and the second highest Aid flow (current US$) of Malawi?
Make the answer very short. 1.34e+06. What is the difference between the highest and the lowest Aid flow (current US$) of Bhutan?
Your answer should be compact. 8.19e+06. What is the difference between the highest and the lowest Aid flow (current US$) of Hungary?
Your response must be concise. 5.44e+06. What is the difference between the highest and the lowest Aid flow (current US$) of Korea (Republic)?
Provide a succinct answer. 5.30e+06. What is the difference between the highest and the lowest Aid flow (current US$) in Malawi?
Your answer should be compact. 1.42e+06. 